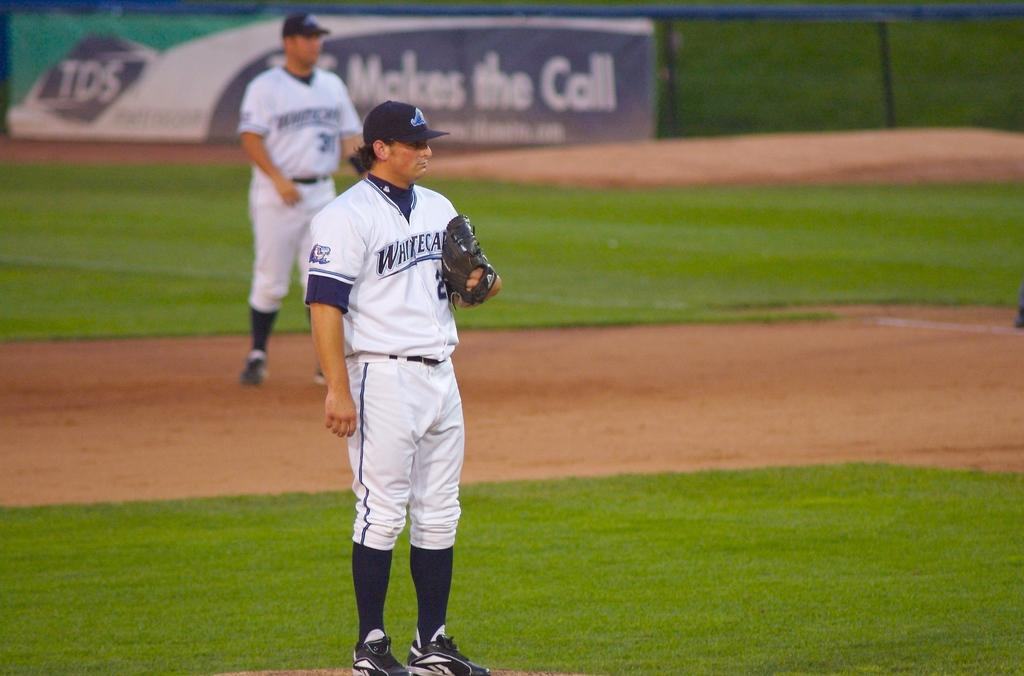Provide a one-sentence caption for the provided image. a baseball field with players with jerseys saying White in front of TDS ad. 